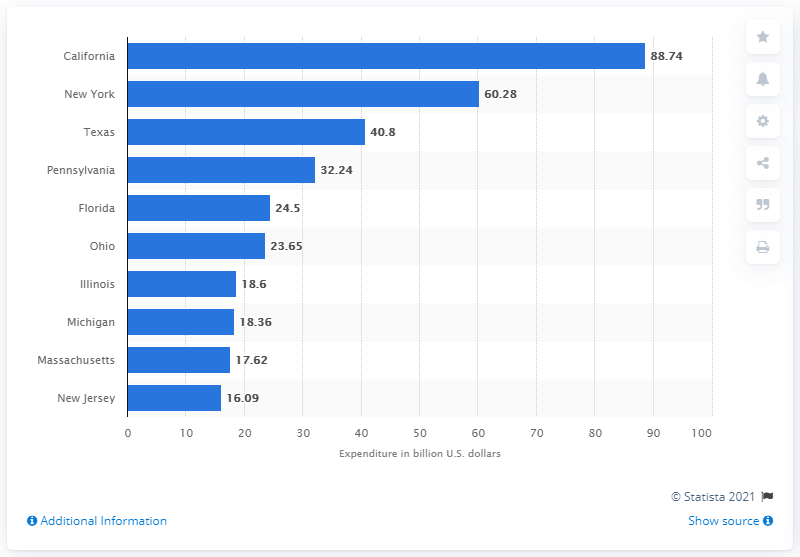Highlight a few significant elements in this photo. The state with the highest Medicaid spending in 2019 was California. 